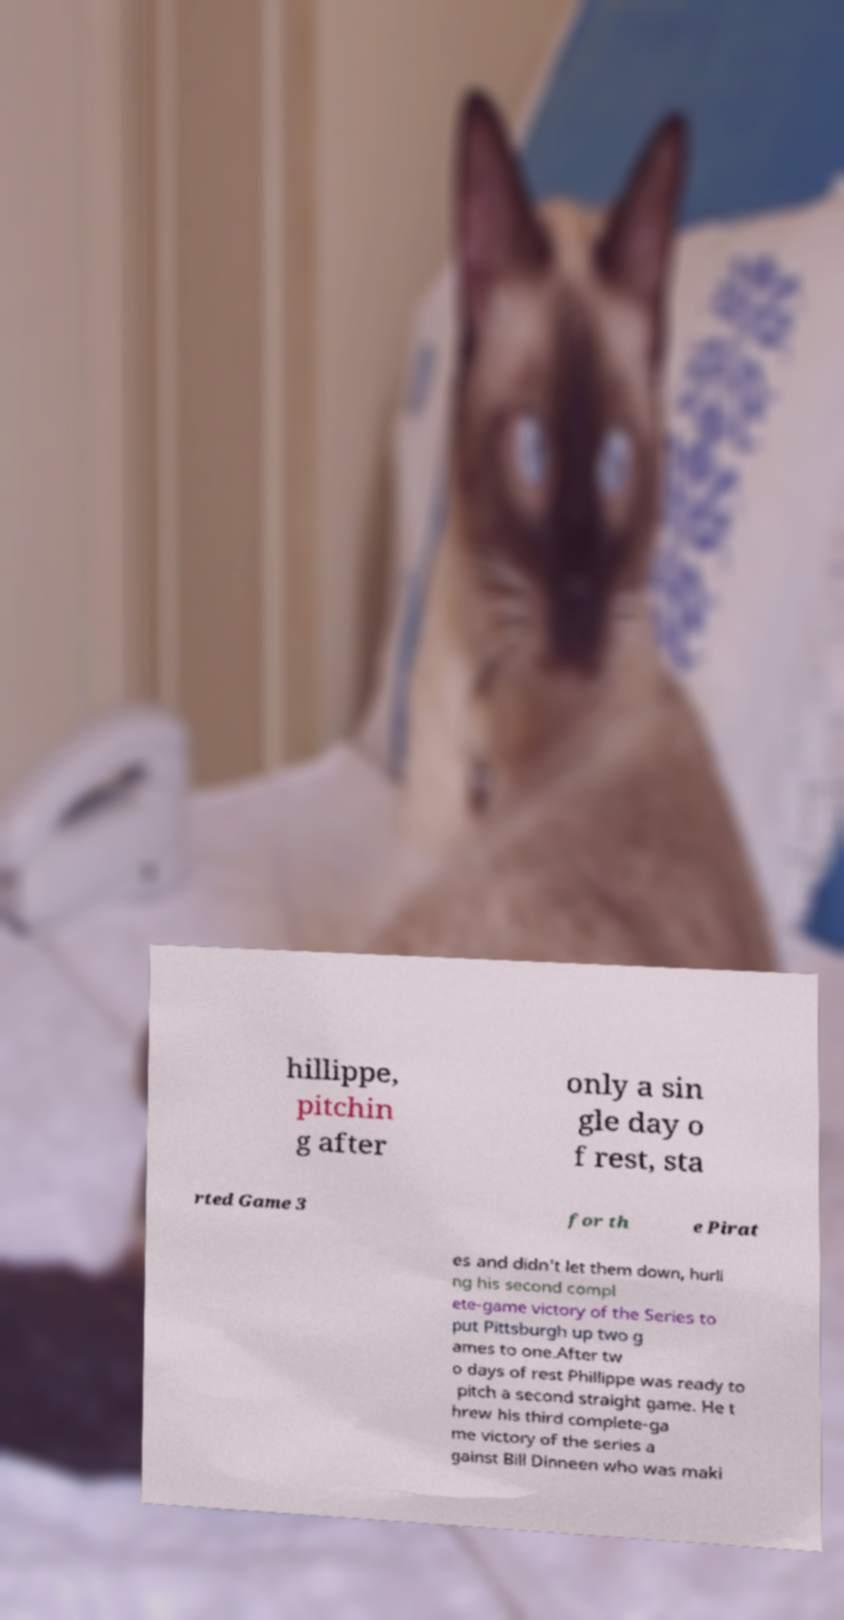Could you extract and type out the text from this image? hillippe, pitchin g after only a sin gle day o f rest, sta rted Game 3 for th e Pirat es and didn't let them down, hurli ng his second compl ete-game victory of the Series to put Pittsburgh up two g ames to one.After tw o days of rest Phillippe was ready to pitch a second straight game. He t hrew his third complete-ga me victory of the series a gainst Bill Dinneen who was maki 